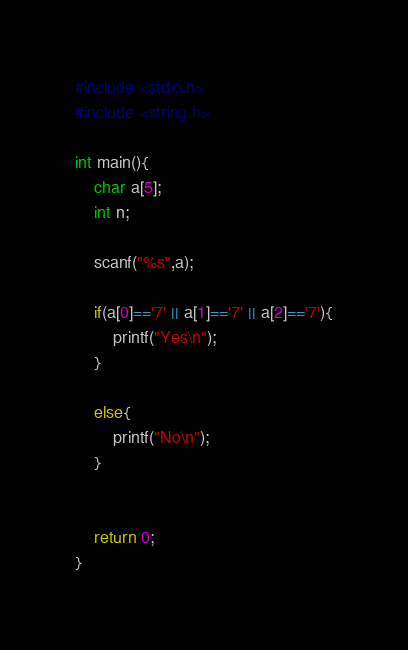Convert code to text. <code><loc_0><loc_0><loc_500><loc_500><_C_>#include <stdio.h>
#include <string.h>

int main(){
    char a[5];
    int n;
    
    scanf("%s",a);
    
    if(a[0]=='7' || a[1]=='7' || a[2]=='7'){
        printf("Yes\n");
    }
    
    else{
        printf("No\n");
    }
    
    
    return 0;
}</code> 